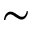Convert formula to latex. <formula><loc_0><loc_0><loc_500><loc_500>\sim</formula> 